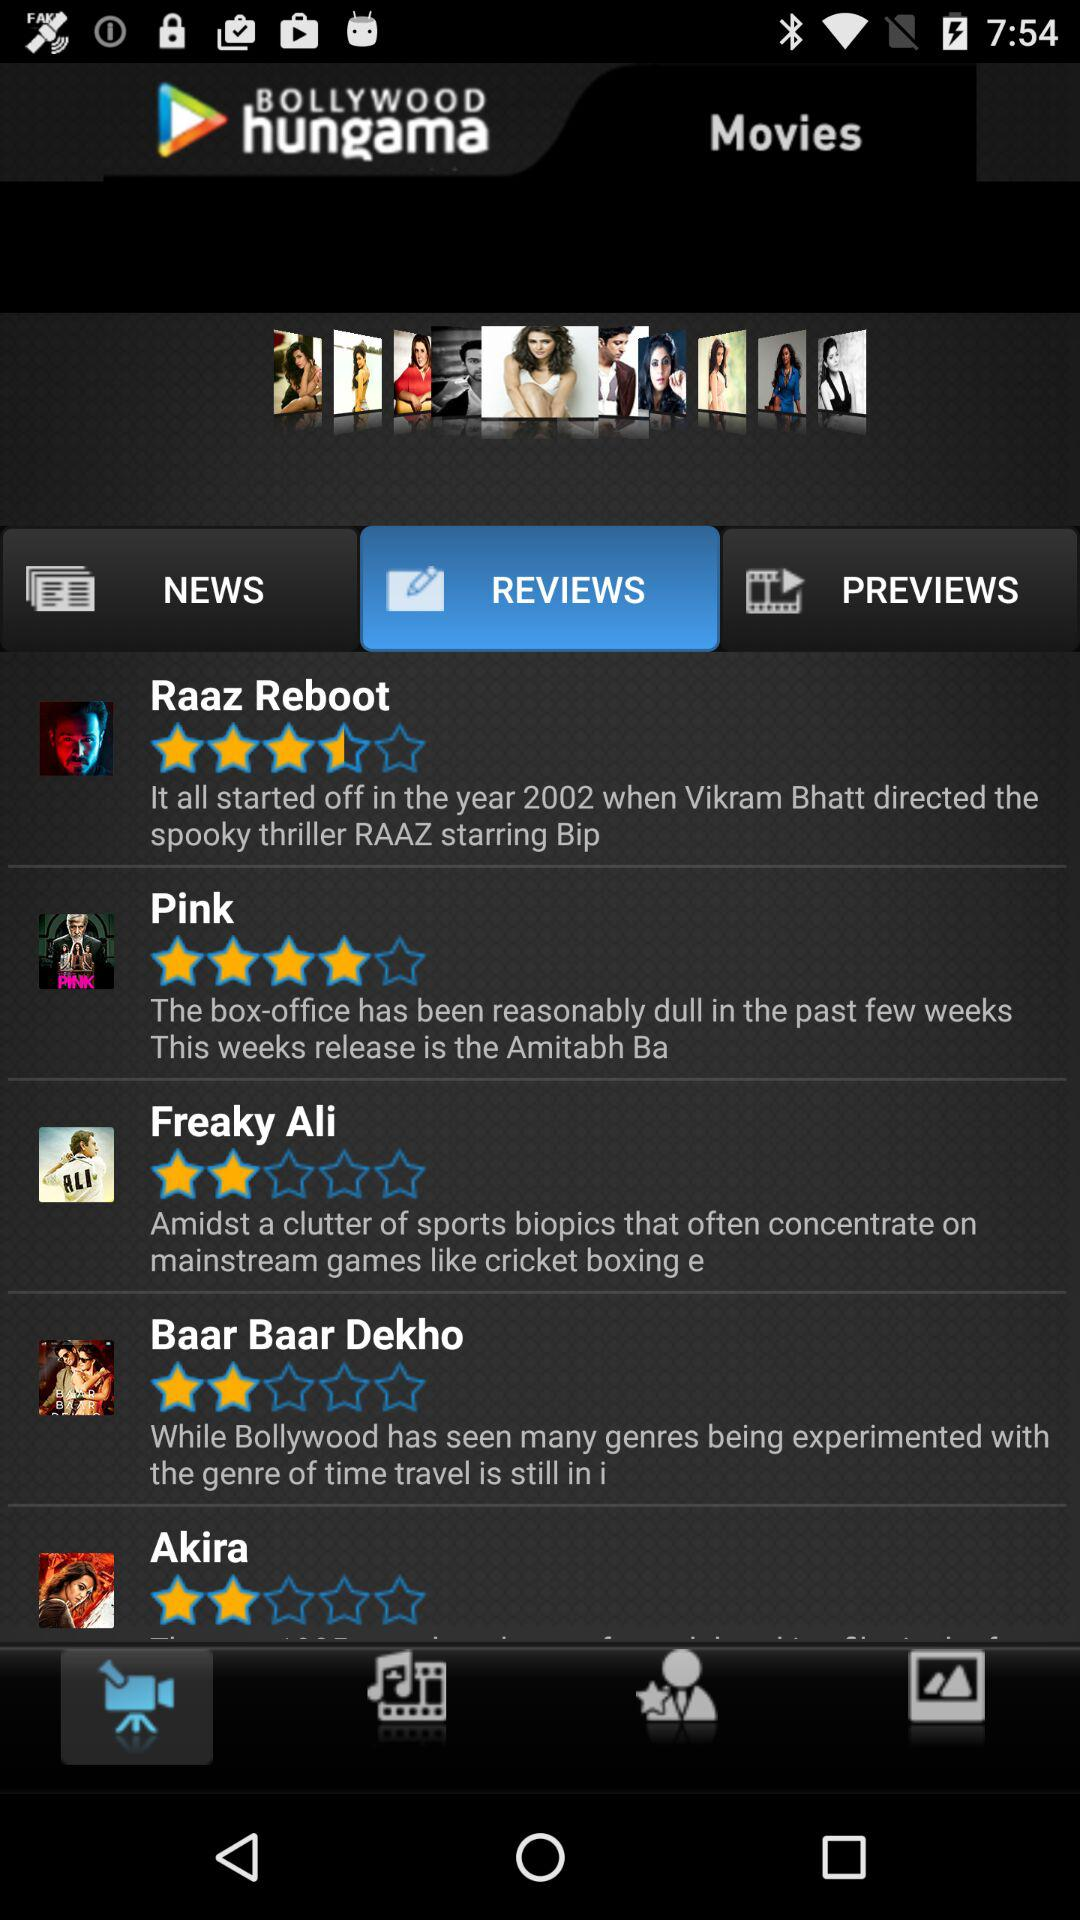What is the rating for "Raaz Reboot"? The rating is 3.5 stars. 